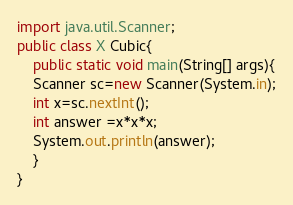<code> <loc_0><loc_0><loc_500><loc_500><_Java_>import java.util.Scanner;
public class X Cubic{
	public static void main(String[] args){
	Scanner sc=new Scanner(System.in);
	int x=sc.nextInt();
	int answer =x*x*x;
	System.out.println(answer);
	}
}</code> 